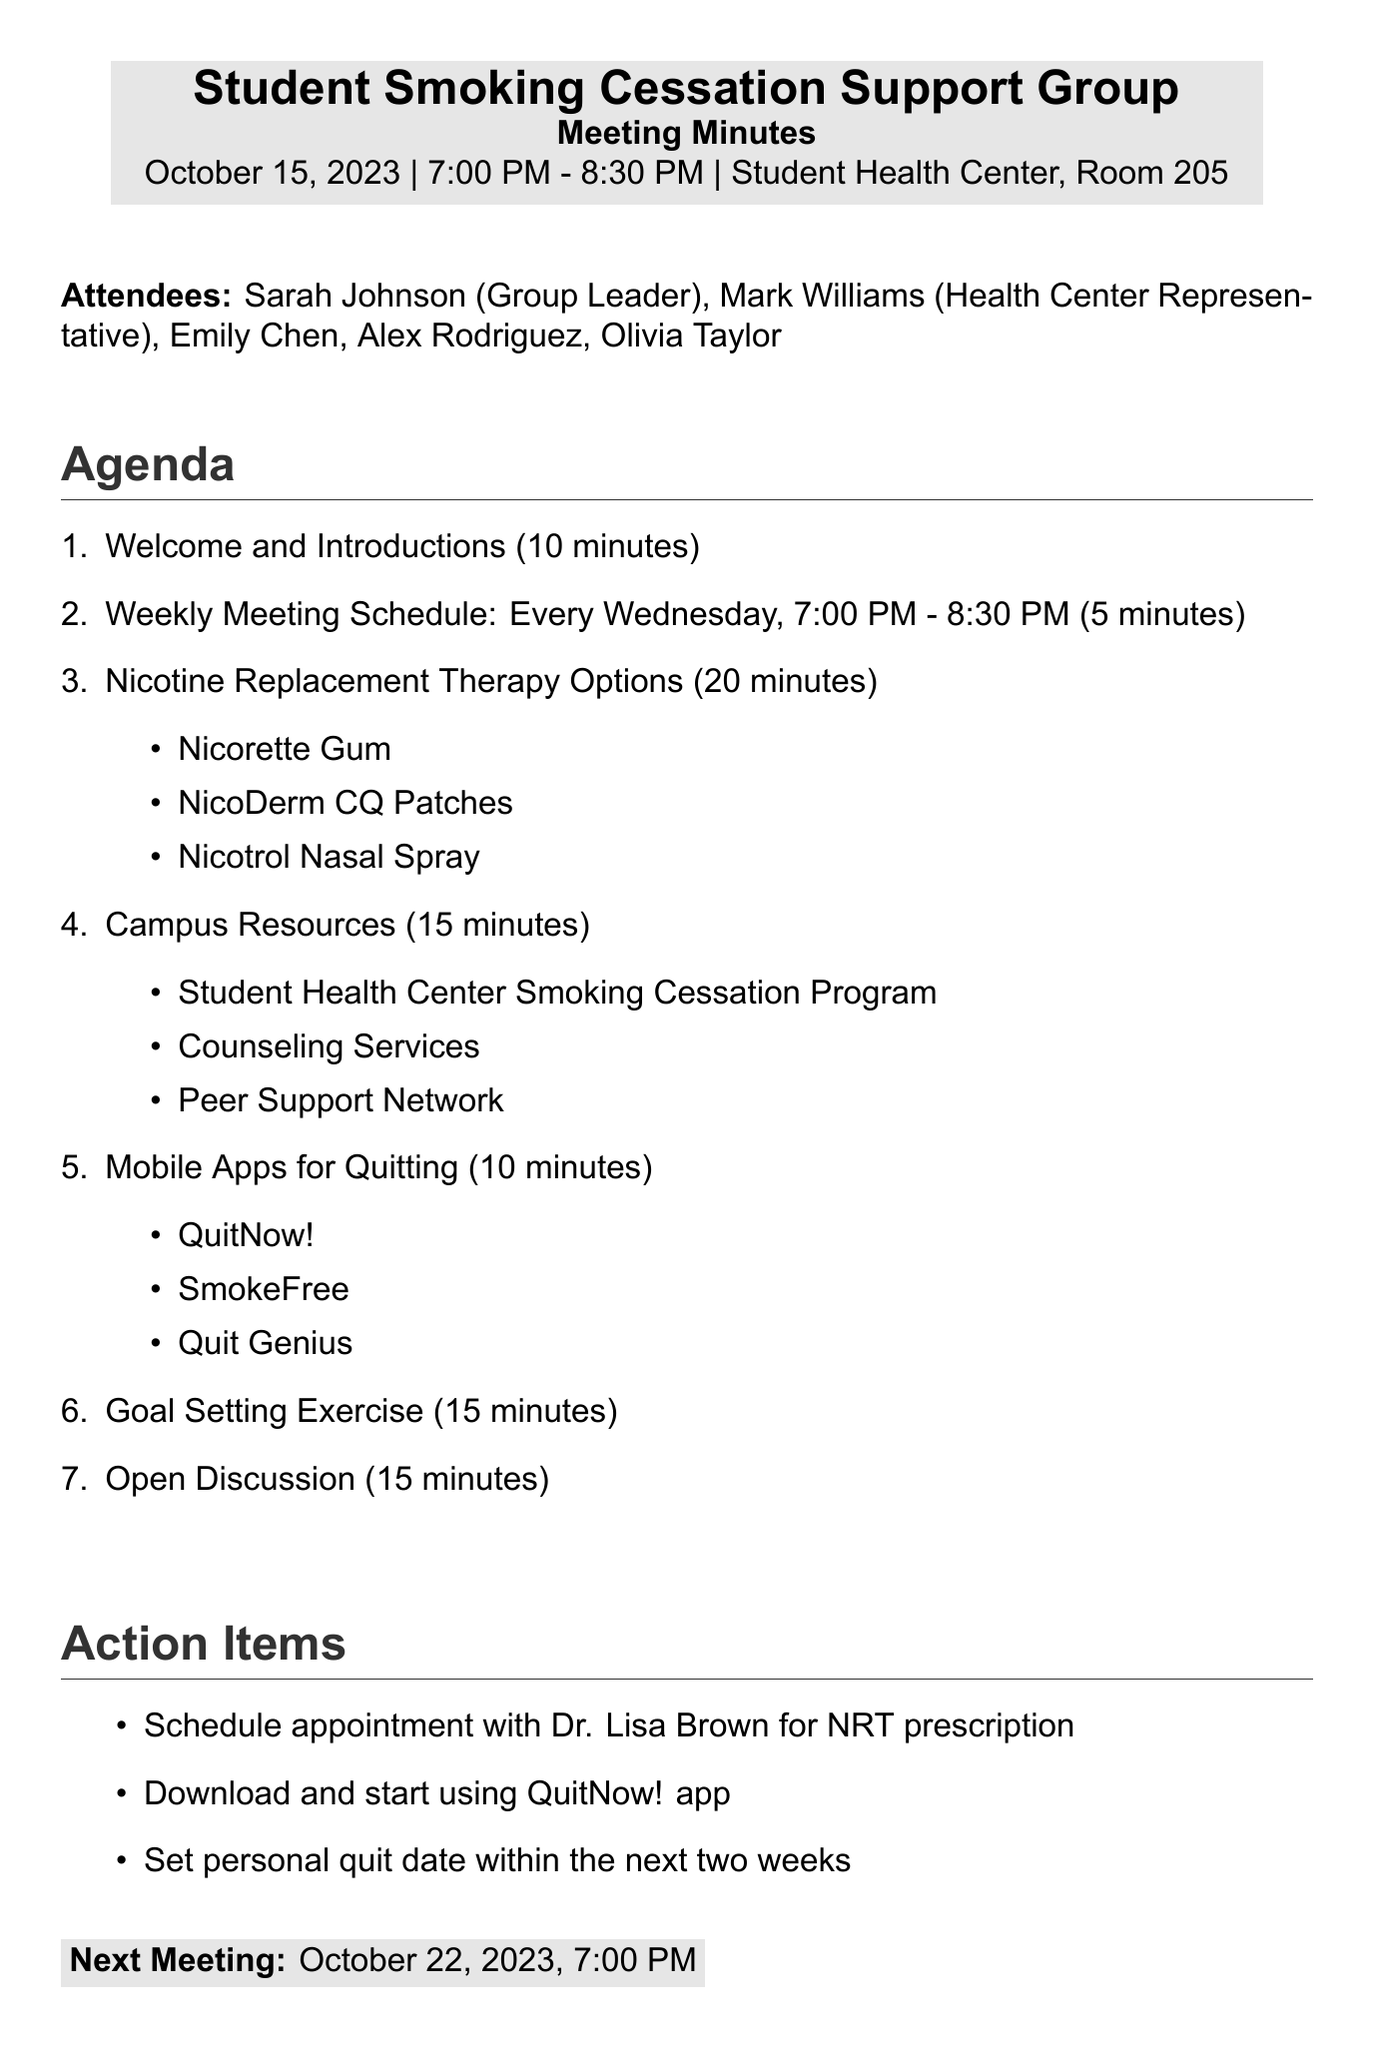what is the meeting title? The meeting title is clearly stated at the beginning of the document.
Answer: Student Smoking Cessation Support Group who is the group leader? The document lists all attendees, including the group leader.
Answer: Sarah Johnson when is the next meeting scheduled? The date and time of the next meeting are provided at the end of the document.
Answer: October 22, 2023, 7:00 PM how long is the "Goal Setting Exercise"? The duration of each agenda item is specified in the meeting minutes.
Answer: 15 minutes what are two options for Nicotine Replacement Therapy? The document provides a list of options discussed during the meeting.
Answer: Nicorette Gum, NicoDerm CQ Patches how often does the support group meet? The meeting schedule is mentioned in the agenda items section.
Answer: Every Wednesday what are some campus resources mentioned? The document includes a list of resources available for students looking to quit smoking.
Answer: Student Health Center Smoking Cessation Program, Counseling Services, Peer Support Network what action item involves downloading an app? The specific action items are listed in the document.
Answer: Download and start using QuitNow! app 